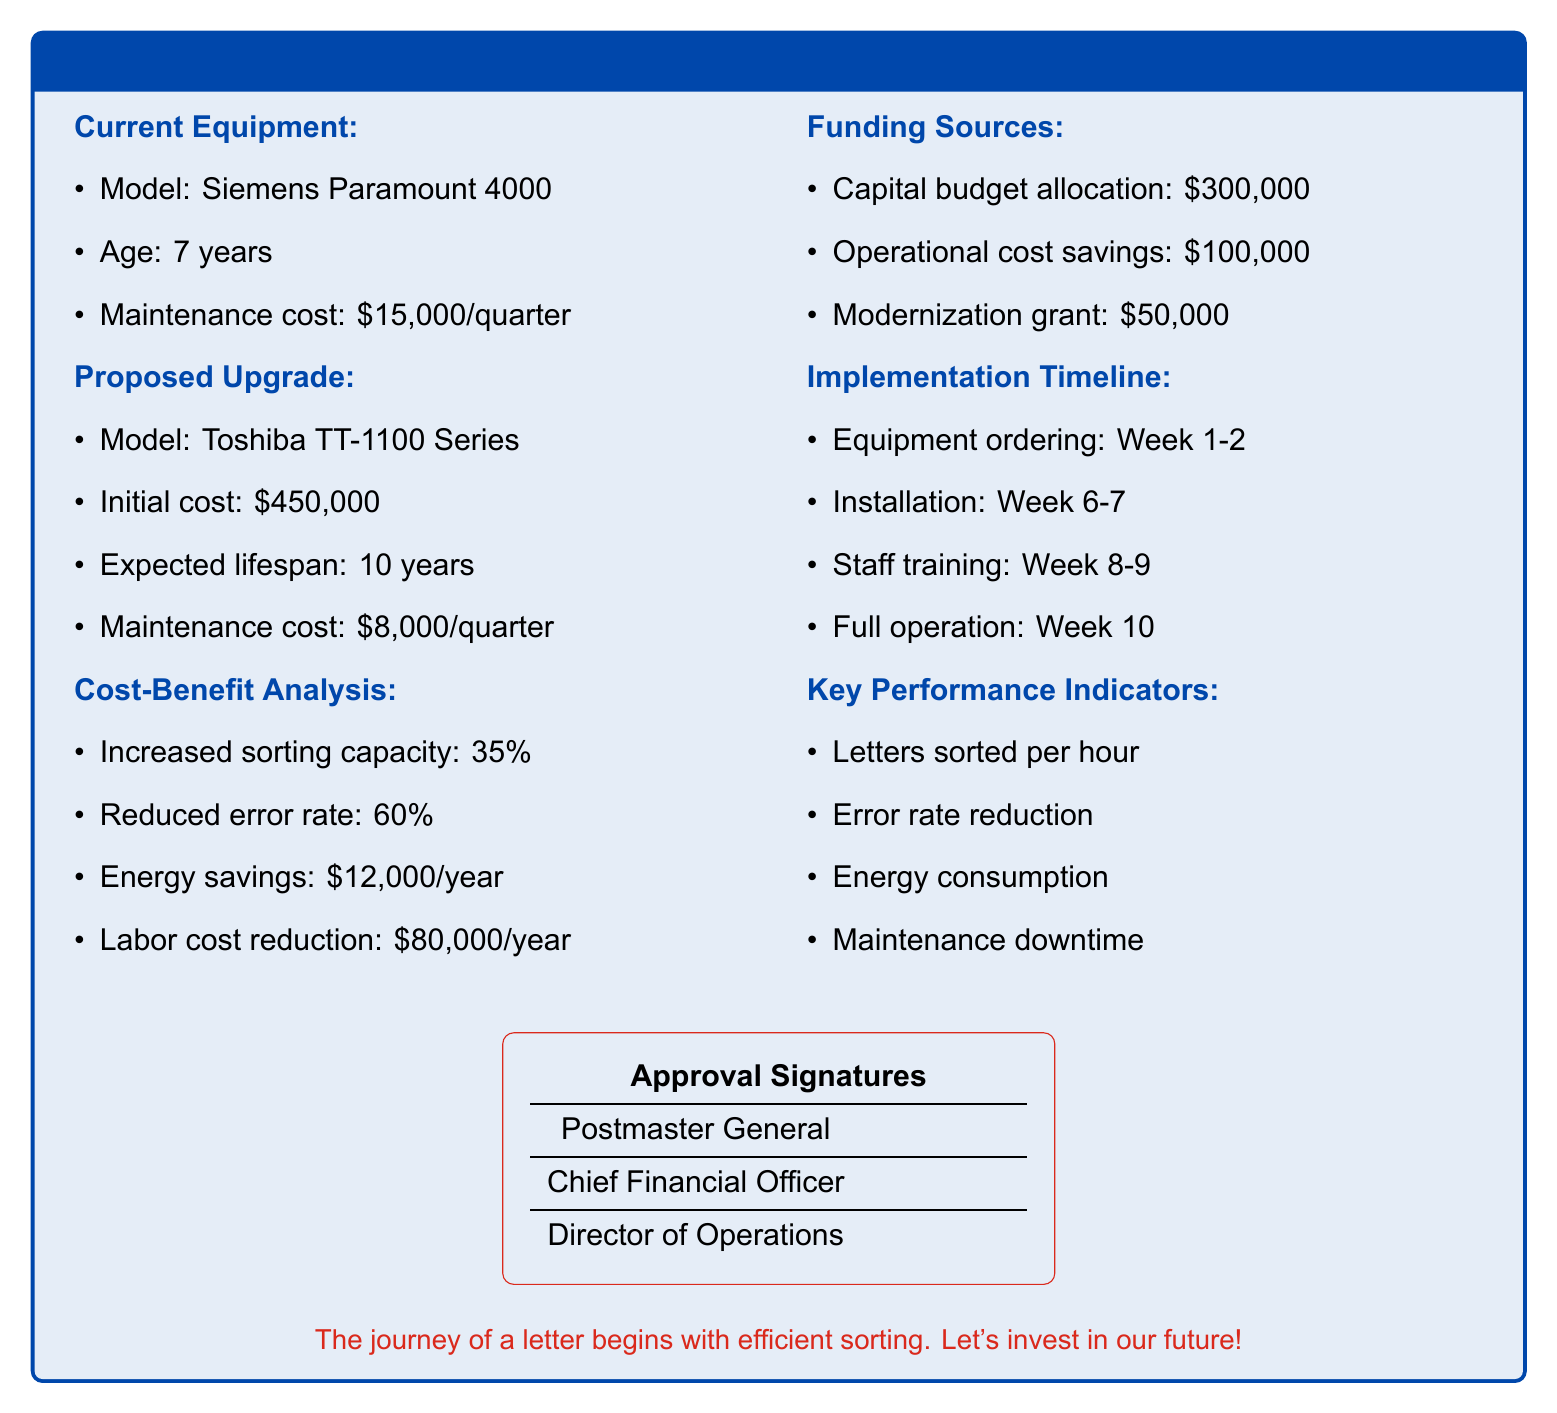What is the current maintenance cost? The current maintenance cost is specified in the document for Siemens Paramount 4000, which is $15,000 per quarter.
Answer: $15,000/quarter What is the initial cost of the proposed upgrade? The initial cost for the Toshiba TT-1100 Series is mentioned as $450,000 in the document.
Answer: $450,000 How much will be saved in energy annually? The document states that annual energy savings will amount to $12,000.
Answer: $12,000/year What is the expected lifespan of the new sorting equipment? The expected lifespan of the Toshiba TT-1100 Series is outlined as 10 years.
Answer: 10 years What funding source contributes $50,000? The document notes that a modernization grant will contribute this amount towards the project.
Answer: Modernization grant What is the percentage increase in sorting capacity? According to the cost-benefit analysis, there is a 35% increase in sorting capacity projected.
Answer: 35% How many weeks is the installation planned to take? The installation timeline shows installation is planned to take place over 2 weeks, from week 6 to 7.
Answer: 2 weeks What is one of the key performance indicators? The document lists several key performance indicators, one of which is letters sorted per hour.
Answer: Letters sorted per hour What is the reduction in maintenance cost with the new equipment? The reduction in maintenance cost when switching to the new equipment is calculated as $15,000 - $8,000, resulting in a savings of $7,000 per quarter.
Answer: $7,000/quarter 